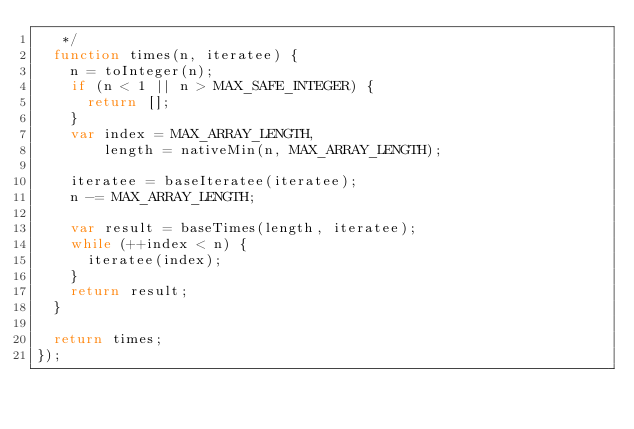Convert code to text. <code><loc_0><loc_0><loc_500><loc_500><_JavaScript_>   */
  function times(n, iteratee) {
    n = toInteger(n);
    if (n < 1 || n > MAX_SAFE_INTEGER) {
      return [];
    }
    var index = MAX_ARRAY_LENGTH,
        length = nativeMin(n, MAX_ARRAY_LENGTH);

    iteratee = baseIteratee(iteratee);
    n -= MAX_ARRAY_LENGTH;

    var result = baseTimes(length, iteratee);
    while (++index < n) {
      iteratee(index);
    }
    return result;
  }

  return times;
});
</code> 